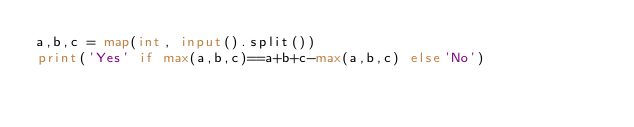Convert code to text. <code><loc_0><loc_0><loc_500><loc_500><_Python_>a,b,c = map(int, input().split())
print('Yes' if max(a,b,c)==a+b+c-max(a,b,c) else'No')
</code> 